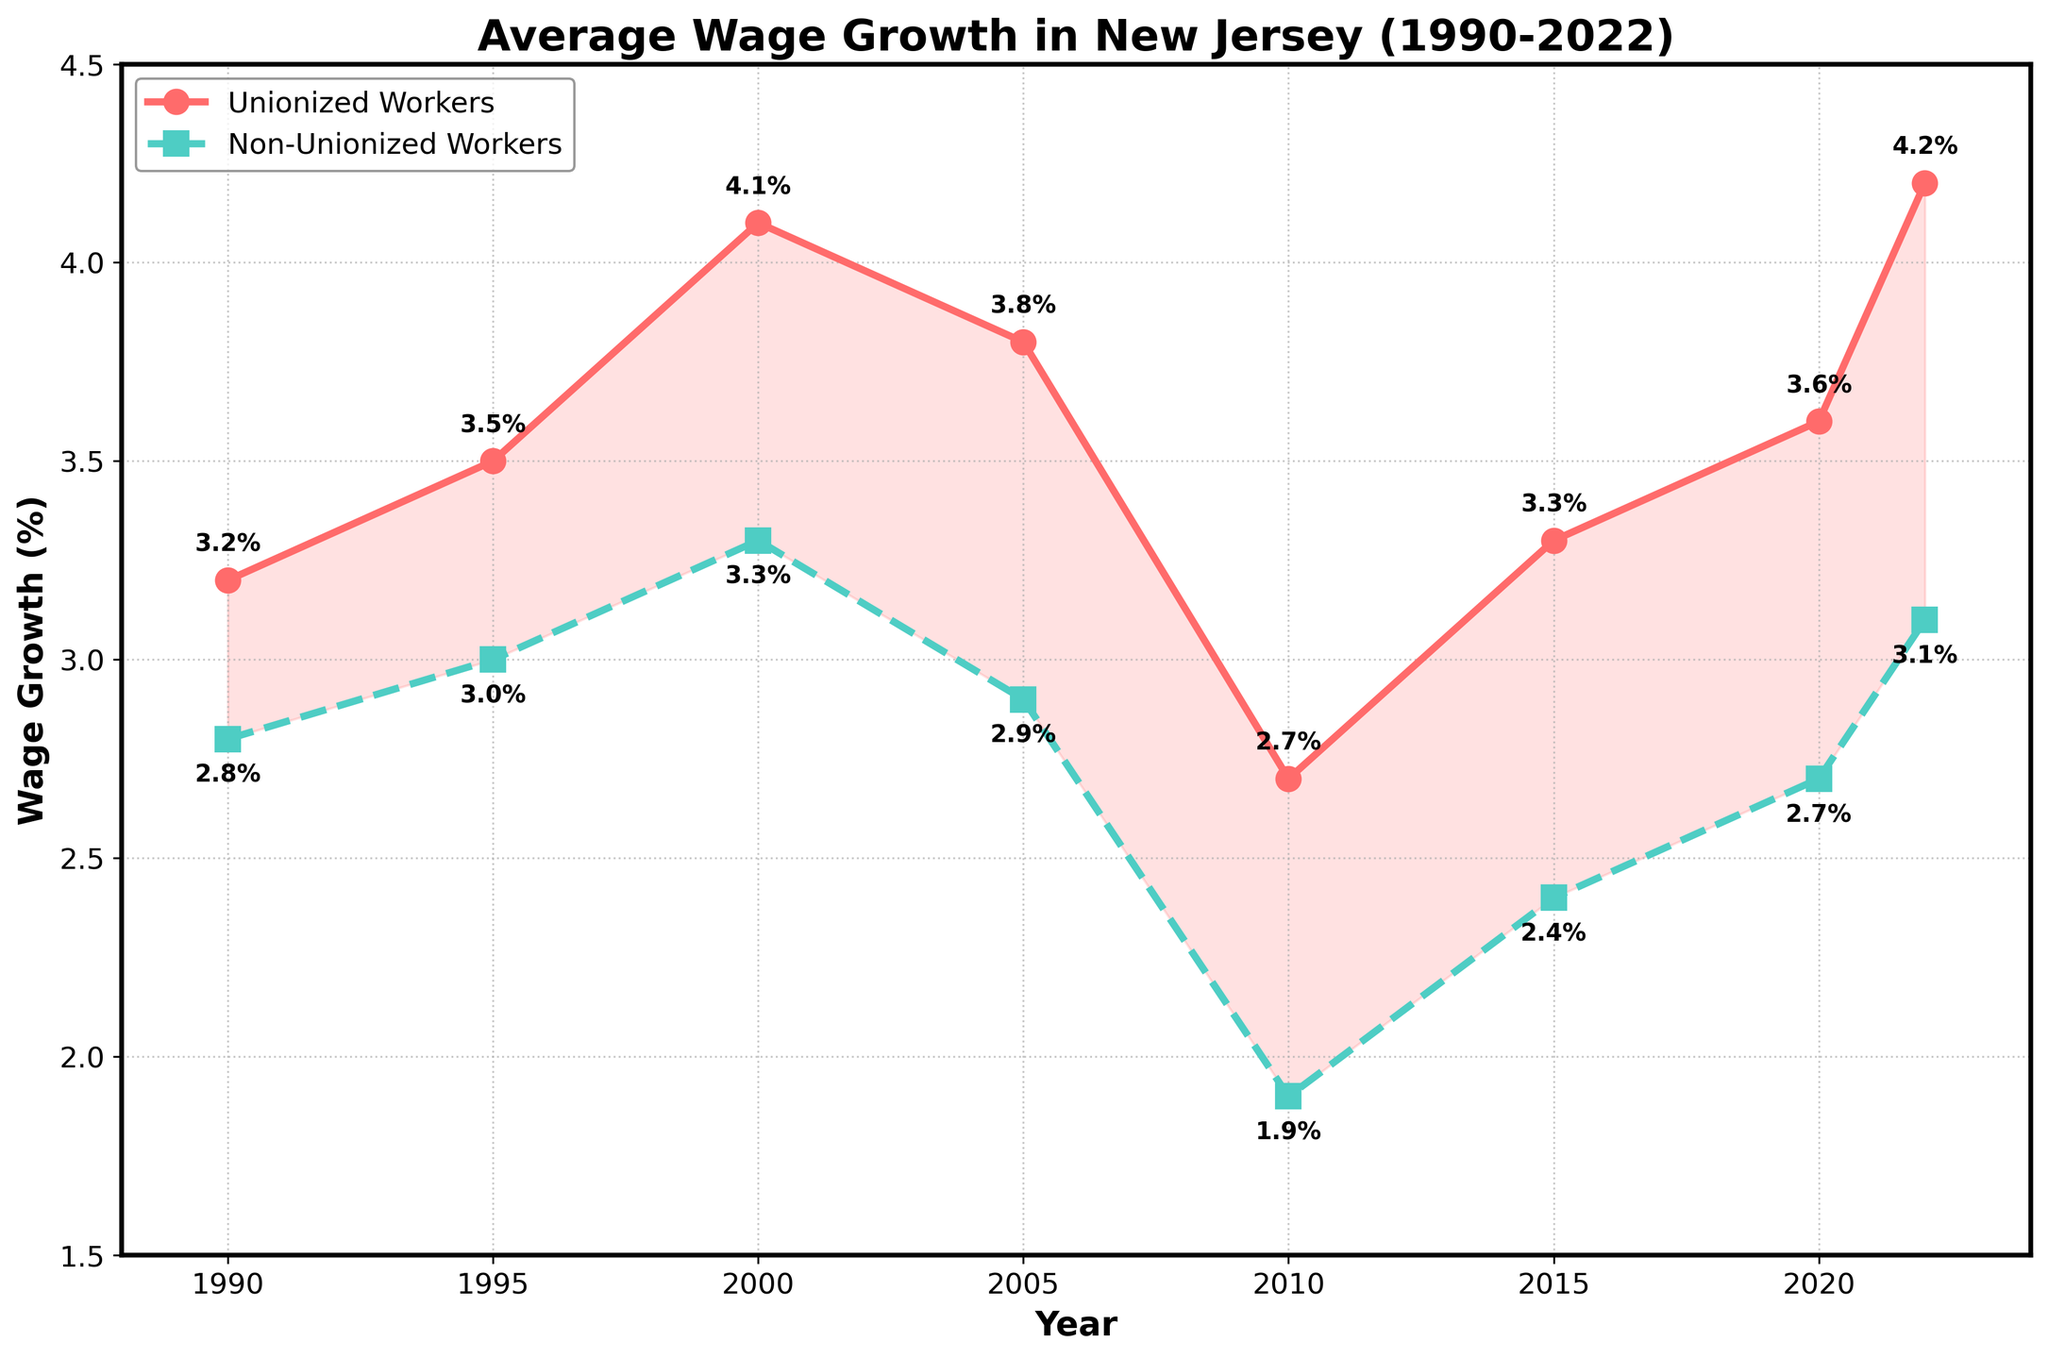What is the overall trend in the wage growth for unionized workers from 1990 to 2022? Observing the line representing unionized workers, it shows a consistent upward trend with slight fluctuations over the years, starting at 3.2% in 1990 and reaching 4.2% in 2022.
Answer: Upward trend In which year did the wage growth for non-unionized workers surpass the wage growth for unionized workers? By comparing the lines for each year, non-unionized workers never surpassed unionized workers. In all shown years, wage growth for unionized workers was always higher.
Answer: Never What was the difference in wage growth between unionized and non-unionized workers in 2022? In 2022, wage growth for unionized workers was 4.2% and for non-unionized workers was 3.1%. The difference is 4.2% - 3.1% = 1.1%.
Answer: 1.1% Between which consecutive years did unionized workers experience the most significant decrease in wage growth? By examining the plots, it is evident that the most significant decrease in wage growth for unionized workers occurred between 2000 (4.1%) and 2005 (3.8%), which is a 0.3% decrease.
Answer: 2000 to 2005 What is the average wage growth for unionized workers and non-unionized workers over the given period? The average for unionized workers is calculated by summing the growth rates and dividing by the number of years: (3.2 + 3.5 + 4.1 + 3.8 + 2.7 + 3.3 + 3.6 + 4.2)/8 = 28.4/8 = 3.55%. For non-unionized workers: (2.8 + 3.0 + 3.3 + 2.9 + 1.9 + 2.4 + 2.7 + 3.1)/8 = 22.1/8 = 2.76%.
Answer: Unionized: 3.55%, Non-unionized: 2.76% Which periods show the most significant disparity in wage growth between unionized and non-unionized workers? The biggest disparities are seen in 2005 and 2010 where the gaps are 0.9% (3.8% - 2.9%) and 0.8% (2.7% - 1.9%) respectively.
Answer: 2005 and 2010 In 2015, what is the sum of wage growth percentages for both unionized and non-unionized workers? In 2015, wage growth for unionized workers was 3.3% and for non-unionized workers was 2.4%. Summing them gives 3.3% + 2.4% = 5.7%.
Answer: 5.7% How does the gap between unionized and non-unionized wage growth change from 1990 to 2022? In 1990, the gap was 3.2% - 2.8% = 0.4%. In 2022, the gap increased to 4.2% - 3.1% = 1.1%. Therefore, the gap increased by 1.1% - 0.4% = 0.7% over the period.
Answer: The gap increased by 0.7% Which group had more consistent wage growth from 1990 to 2022, unionized or non-unionized workers? By examining the lines, the wage growth for unionized workers shows fewer fluctuations compared to the more fluctuating trend of non-unionized workers.
Answer: Unionized workers 